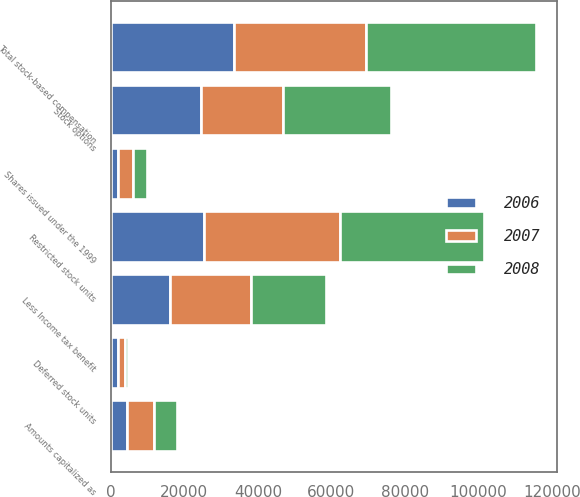Convert chart. <chart><loc_0><loc_0><loc_500><loc_500><stacked_bar_chart><ecel><fcel>Stock options<fcel>Deferred stock units<fcel>Restricted stock units<fcel>Shares issued under the 1999<fcel>Amounts capitalized as<fcel>Total stock-based compensation<fcel>Less Income tax benefit<nl><fcel>2007<fcel>22381<fcel>1885<fcel>37005<fcel>4064<fcel>7436<fcel>35830<fcel>22069<nl><fcel>2008<fcel>29171<fcel>925<fcel>38958<fcel>3854<fcel>6353<fcel>46175<fcel>20380<nl><fcel>2006<fcel>24572<fcel>1976<fcel>25410<fcel>1903<fcel>4293<fcel>33557<fcel>16011<nl></chart> 